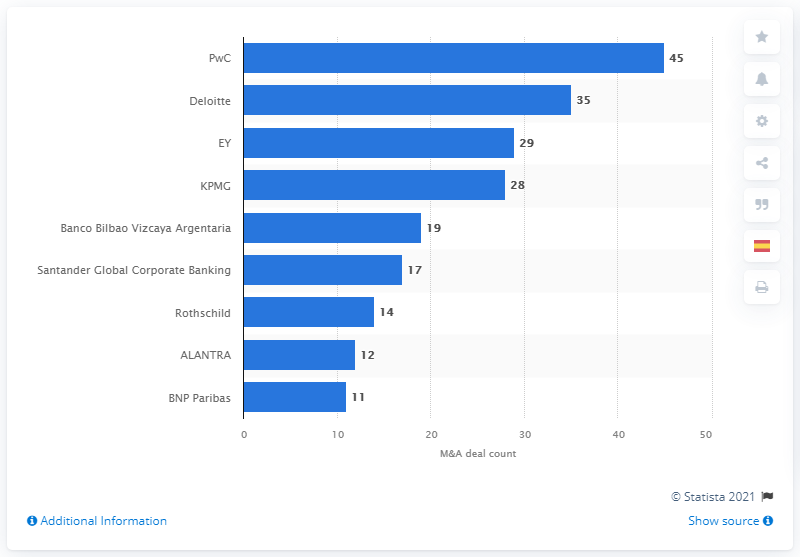Specify some key components in this picture. In 2016, PwC had a total of 45 deals. 